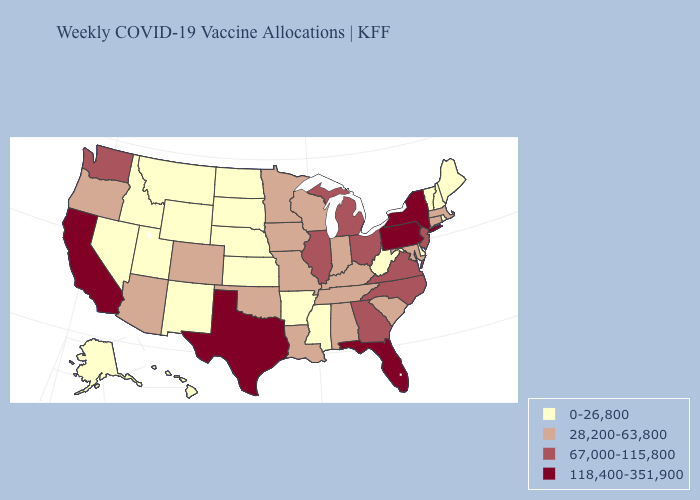What is the lowest value in the MidWest?
Write a very short answer. 0-26,800. Among the states that border Delaware , does New Jersey have the highest value?
Write a very short answer. No. Does Kansas have the same value as Vermont?
Concise answer only. Yes. Does Texas have a higher value than New York?
Concise answer only. No. Which states hav the highest value in the South?
Answer briefly. Florida, Texas. What is the value of Wyoming?
Quick response, please. 0-26,800. Among the states that border Arizona , which have the highest value?
Quick response, please. California. What is the lowest value in the USA?
Be succinct. 0-26,800. Is the legend a continuous bar?
Give a very brief answer. No. Among the states that border Montana , which have the highest value?
Concise answer only. Idaho, North Dakota, South Dakota, Wyoming. Name the states that have a value in the range 28,200-63,800?
Answer briefly. Alabama, Arizona, Colorado, Connecticut, Indiana, Iowa, Kentucky, Louisiana, Maryland, Massachusetts, Minnesota, Missouri, Oklahoma, Oregon, South Carolina, Tennessee, Wisconsin. What is the value of New Mexico?
Answer briefly. 0-26,800. Which states have the highest value in the USA?
Write a very short answer. California, Florida, New York, Pennsylvania, Texas. What is the lowest value in states that border Vermont?
Quick response, please. 0-26,800. What is the lowest value in the South?
Give a very brief answer. 0-26,800. 